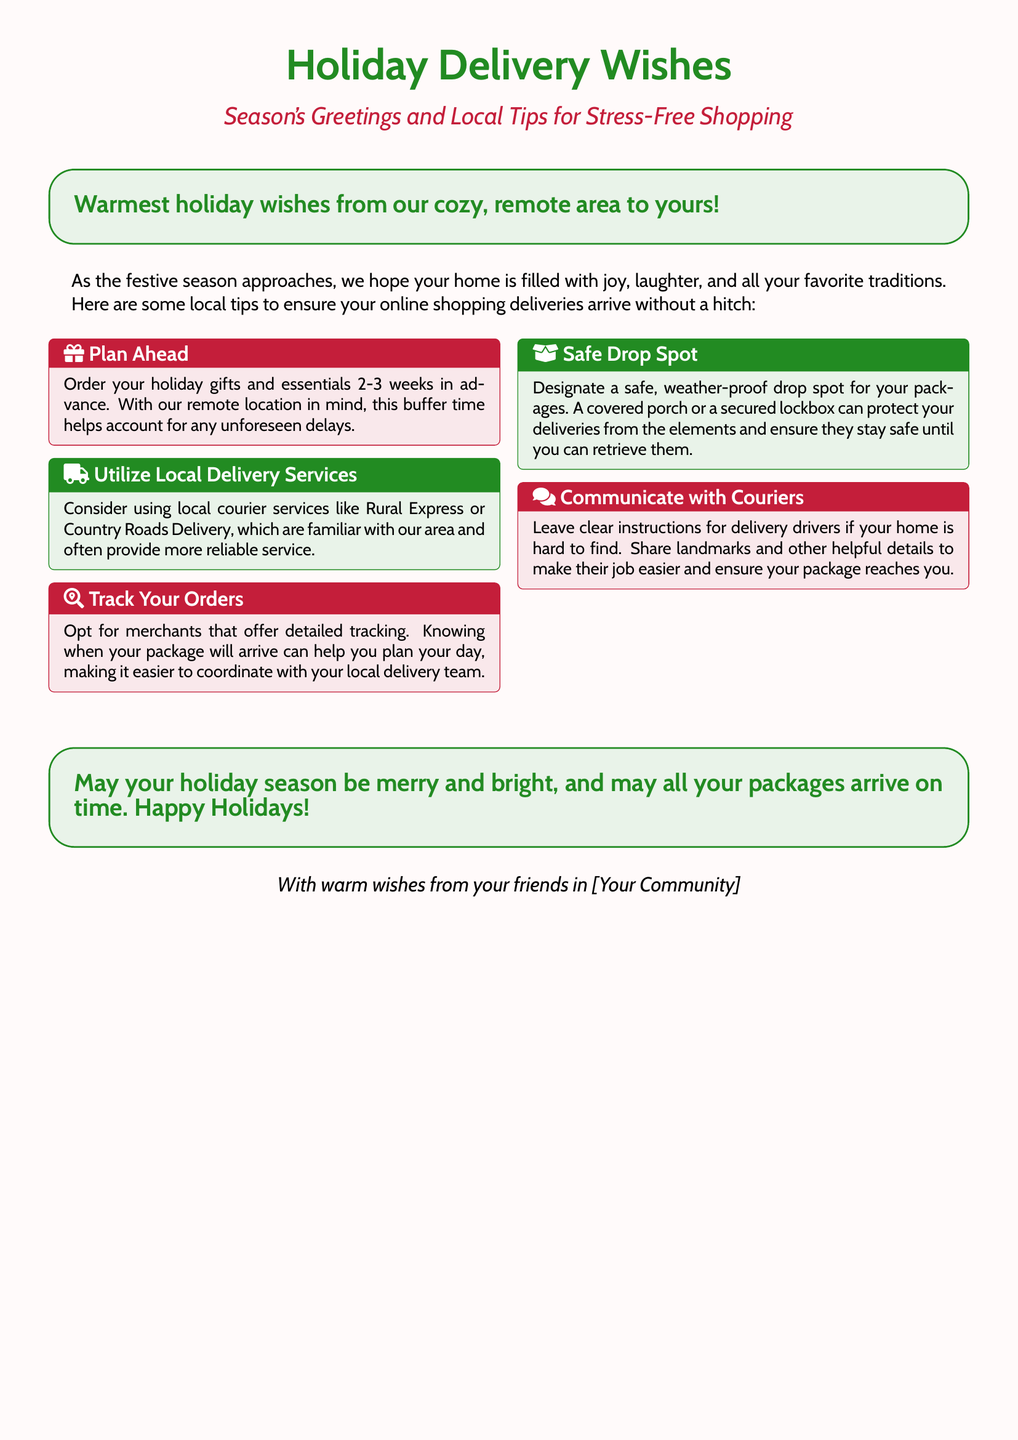What is the title of the card? The title is prominently displayed at the top of the card, reading "Holiday Delivery Wishes."
Answer: Holiday Delivery Wishes What color is used for the greeting text? The greeting text is colored in cardinal red, adding a festive touch.
Answer: cardinal red How many weeks in advance should you order gifts? The card advises ordering gifts and essentials 2-3 weeks in advance to account for potential delays.
Answer: 2-3 weeks What service is recommended for reliable delivery? The card suggests using local courier services such as Rural Express or Country Roads Delivery for better reliability.
Answer: Rural Express or Country Roads Delivery What is a suggested method for ensuring safe package delivery? The card recommends designating a safe, weather-proof drop spot for packages to protect them until retrieval.
Answer: safe, weather-proof drop spot What should you provide to help delivery drivers? The card highlights the importance of leaving clear instructions, including landmarks, to assist delivery drivers in finding your home.
Answer: clear instructions What is the main theme of the card? The card focuses on offering holiday greetings along with tips specifically for managing online shopping deliveries in remote areas.
Answer: holiday greetings and tips What sentiment is expressed at the end of the card? The end of the card conveys a warm holiday wish for merriment and timely package arrivals.
Answer: merry and bright Who sends the holiday wishes? The holiday wishes are sent from "your friends in [Your Community]," emphasizing community spirit.
Answer: your friends in [Your Community] 